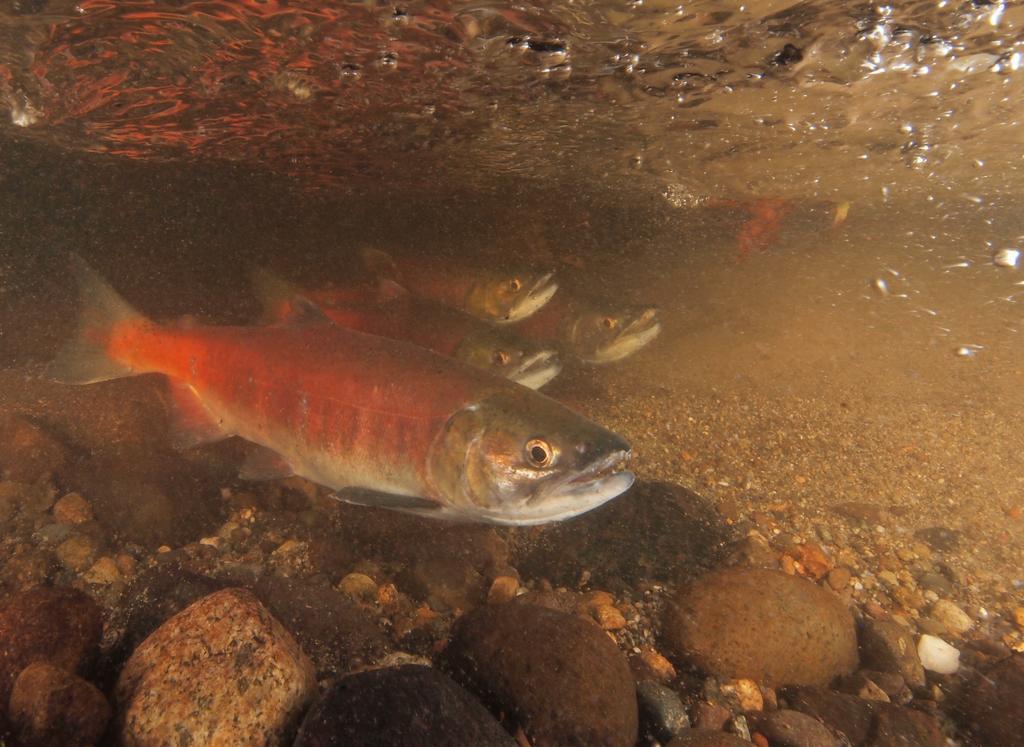In one or two sentences, can you explain what this image depicts? In this image, we can see some fishes and stones in the water. 